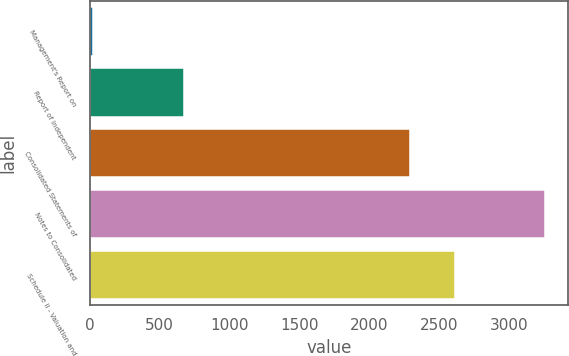Convert chart to OTSL. <chart><loc_0><loc_0><loc_500><loc_500><bar_chart><fcel>Management's Report on<fcel>Report of Independent<fcel>Consolidated Statements of<fcel>Notes to Consolidated<fcel>Schedule II - Valuation and<nl><fcel>24<fcel>670.2<fcel>2285.7<fcel>3255<fcel>2608.8<nl></chart> 